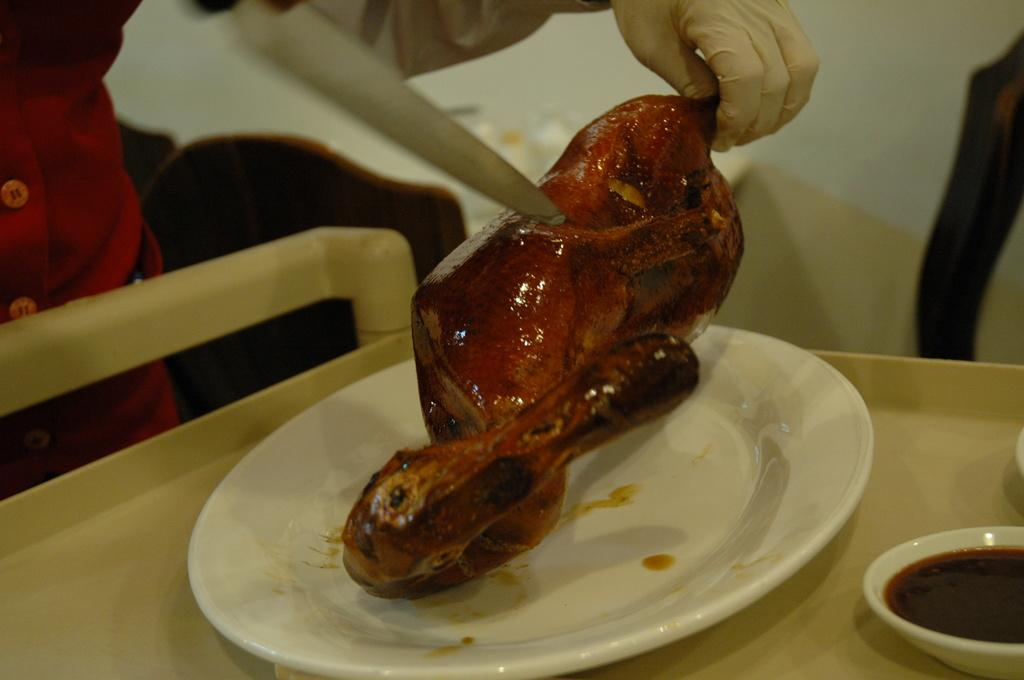Who is present in the image? There is a person in the image. What is the person wearing on their hand? The person is wearing a glove. What object can be seen in the image that is typically used for cutting? There is a knife in the image. What type of food is visible in the image? There is meat in the image. What is the color of the plate in the image? There is a white plate in the image. What is contained in the bowl in the image? There is a bowl with liquid in the image. Where is the scarecrow located in the image? There is no scarecrow present in the image. What type of animal can be seen interacting with the person in the image? There is no animal present in the image; it only features a person, a glove, a knife, meat, a white plate, and a bowl with liquid. 